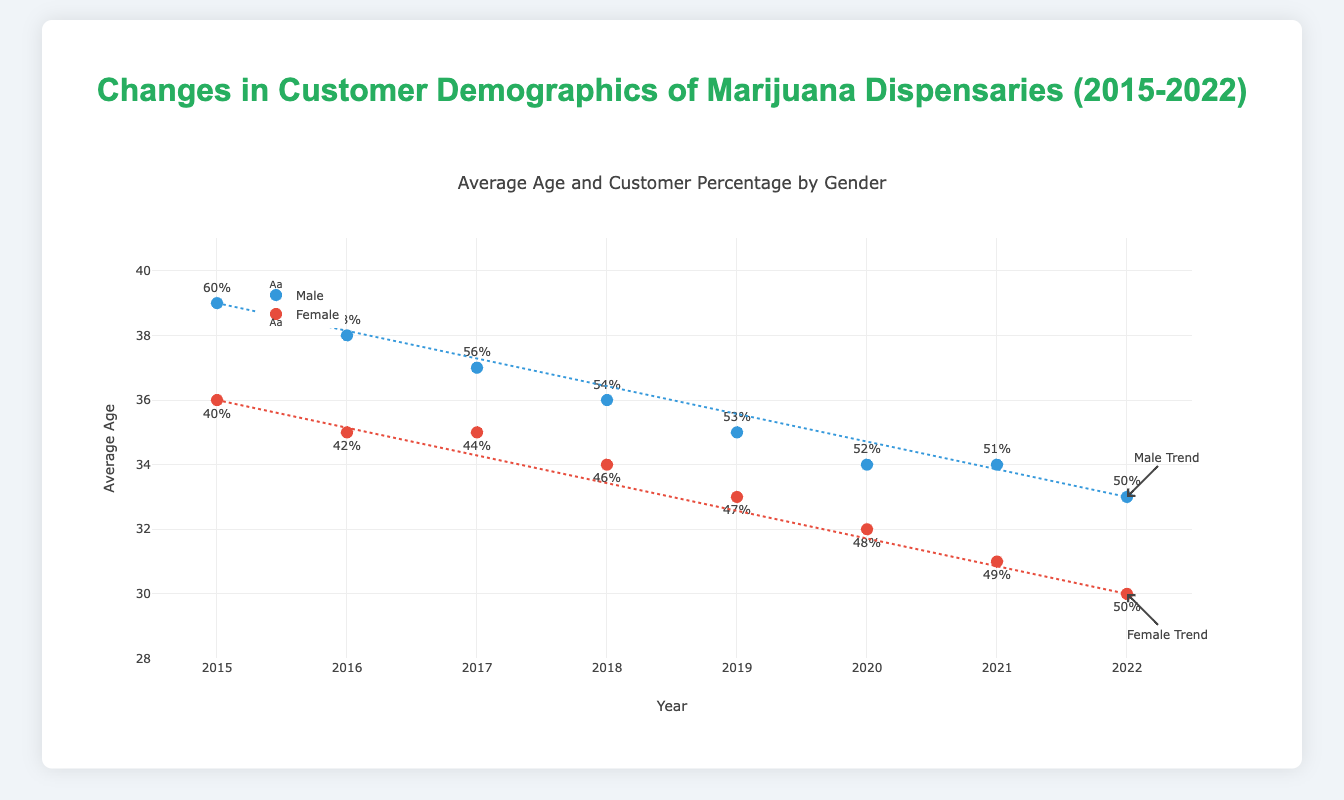What is the title of the figure? The title of the figure is displayed at the top and reads "Changes in Customer Demographics of Marijuana Dispensaries (2015-2022)."
Answer: Changes in Customer Demographics of Marijuana Dispensaries (2015-2022) What color represents the data points for male customers? The data points for male customers are represented by the color blue. You can see this from the blue markers and the corresponding label in the legend.
Answer: Blue How did the average age of male customers change from 2015 to 2022? In 2015, the average age of male customers was 39. By 2022, it had decreased to 33. This can be seen by looking at the data points and the associated trend line for males.
Answer: Decreased from 39 to 33 Between 2020 and 2022, what was the trend in the average age of female customers? From 2020 to 2022, the average age of female customers continued to decrease from 32 in 2020 to 30 in 2022. The trend can be observed from the red data points and the trend line for females.
Answer: Decreasing In which year were the percentages of male and female customers equal? The percentages of male and female customers reached equality in 2022, with both having 50%. This can be viewed from the text labels on the plot displaying the percentages.
Answer: 2022 Looking at the trend lines, whose average age declined more significantly over the years, males or females? The slope of the trend lines suggests that the average age of female customers declined more significantly from 36 to 30, compared to males which declined from 39 to 33.
Answer: Females What is the general trend in the average age of customers from 2015 to 2022? Both male and female customers show a general declining trend in their average age from 2015 to 2022. This can be inferred from the downward slope of both trend lines.
Answer: Declining In what year did the average age of female customers first drop below the average age of male customers? The average age of female customers first dropped below the average age of male customers in 2016. This can be observed from the y-axis values where the red data point for females is lower than the blue data point for males.
Answer: 2016 